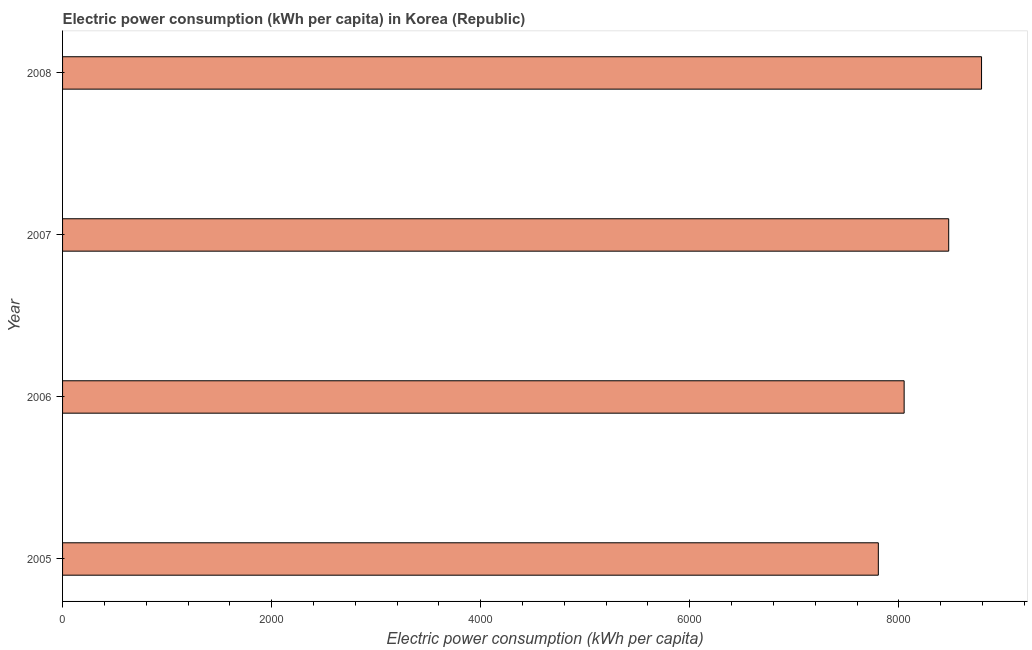Does the graph contain any zero values?
Make the answer very short. No. What is the title of the graph?
Ensure brevity in your answer.  Electric power consumption (kWh per capita) in Korea (Republic). What is the label or title of the X-axis?
Keep it short and to the point. Electric power consumption (kWh per capita). What is the electric power consumption in 2007?
Give a very brief answer. 8477.18. Across all years, what is the maximum electric power consumption?
Give a very brief answer. 8791.29. Across all years, what is the minimum electric power consumption?
Your answer should be compact. 7803.84. In which year was the electric power consumption maximum?
Your answer should be very brief. 2008. In which year was the electric power consumption minimum?
Give a very brief answer. 2005. What is the sum of the electric power consumption?
Give a very brief answer. 3.31e+04. What is the difference between the electric power consumption in 2005 and 2008?
Offer a very short reply. -987.44. What is the average electric power consumption per year?
Offer a terse response. 8280.78. What is the median electric power consumption?
Your response must be concise. 8264. In how many years, is the electric power consumption greater than 2000 kWh per capita?
Make the answer very short. 4. What is the ratio of the electric power consumption in 2006 to that in 2008?
Offer a very short reply. 0.92. Is the electric power consumption in 2007 less than that in 2008?
Provide a succinct answer. Yes. What is the difference between the highest and the second highest electric power consumption?
Your answer should be very brief. 314.11. What is the difference between the highest and the lowest electric power consumption?
Provide a succinct answer. 987.44. In how many years, is the electric power consumption greater than the average electric power consumption taken over all years?
Your answer should be very brief. 2. How many bars are there?
Offer a very short reply. 4. Are all the bars in the graph horizontal?
Your response must be concise. Yes. Are the values on the major ticks of X-axis written in scientific E-notation?
Ensure brevity in your answer.  No. What is the Electric power consumption (kWh per capita) of 2005?
Your response must be concise. 7803.84. What is the Electric power consumption (kWh per capita) in 2006?
Provide a short and direct response. 8050.82. What is the Electric power consumption (kWh per capita) of 2007?
Your answer should be compact. 8477.18. What is the Electric power consumption (kWh per capita) of 2008?
Offer a very short reply. 8791.29. What is the difference between the Electric power consumption (kWh per capita) in 2005 and 2006?
Your answer should be very brief. -246.98. What is the difference between the Electric power consumption (kWh per capita) in 2005 and 2007?
Provide a short and direct response. -673.34. What is the difference between the Electric power consumption (kWh per capita) in 2005 and 2008?
Keep it short and to the point. -987.44. What is the difference between the Electric power consumption (kWh per capita) in 2006 and 2007?
Give a very brief answer. -426.36. What is the difference between the Electric power consumption (kWh per capita) in 2006 and 2008?
Offer a terse response. -740.46. What is the difference between the Electric power consumption (kWh per capita) in 2007 and 2008?
Ensure brevity in your answer.  -314.11. What is the ratio of the Electric power consumption (kWh per capita) in 2005 to that in 2006?
Ensure brevity in your answer.  0.97. What is the ratio of the Electric power consumption (kWh per capita) in 2005 to that in 2007?
Give a very brief answer. 0.92. What is the ratio of the Electric power consumption (kWh per capita) in 2005 to that in 2008?
Make the answer very short. 0.89. What is the ratio of the Electric power consumption (kWh per capita) in 2006 to that in 2008?
Offer a terse response. 0.92. 